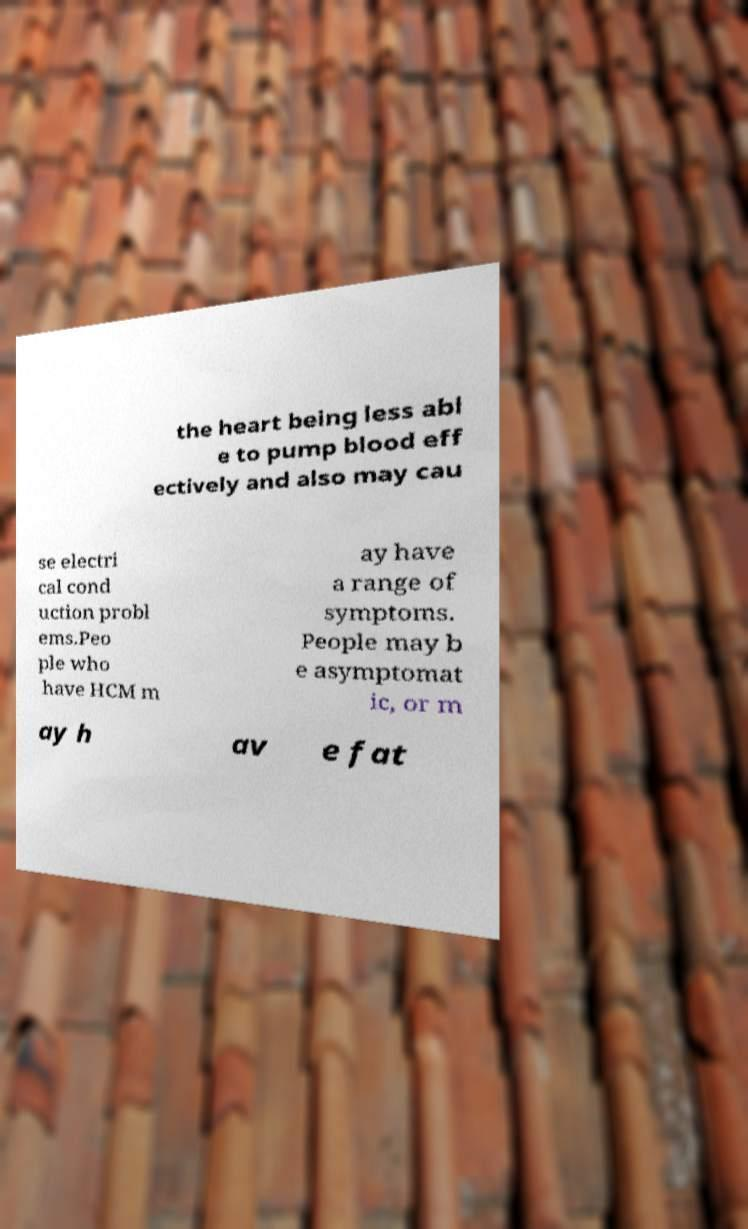There's text embedded in this image that I need extracted. Can you transcribe it verbatim? the heart being less abl e to pump blood eff ectively and also may cau se electri cal cond uction probl ems.Peo ple who have HCM m ay have a range of symptoms. People may b e asymptomat ic, or m ay h av e fat 